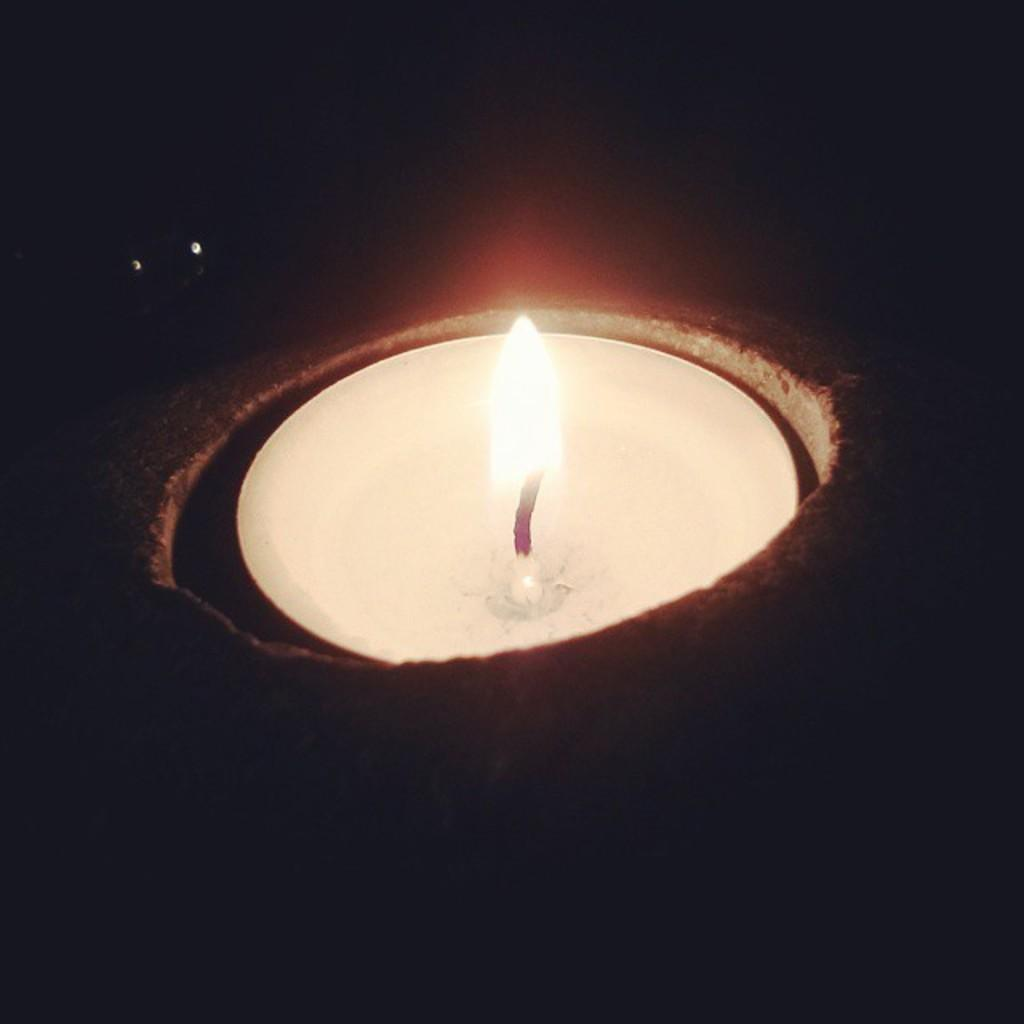What object is present in the image? There is a candle in the image. What color is the candle? The candle is white in color. Is the candle lit or unlit? The candle is lit. What can be observed about the background of the image? The background of the image is black. Can you see a crown on the yak in the image? There is no yak or crown present in the image; it only features a lit white candle against a black background. 